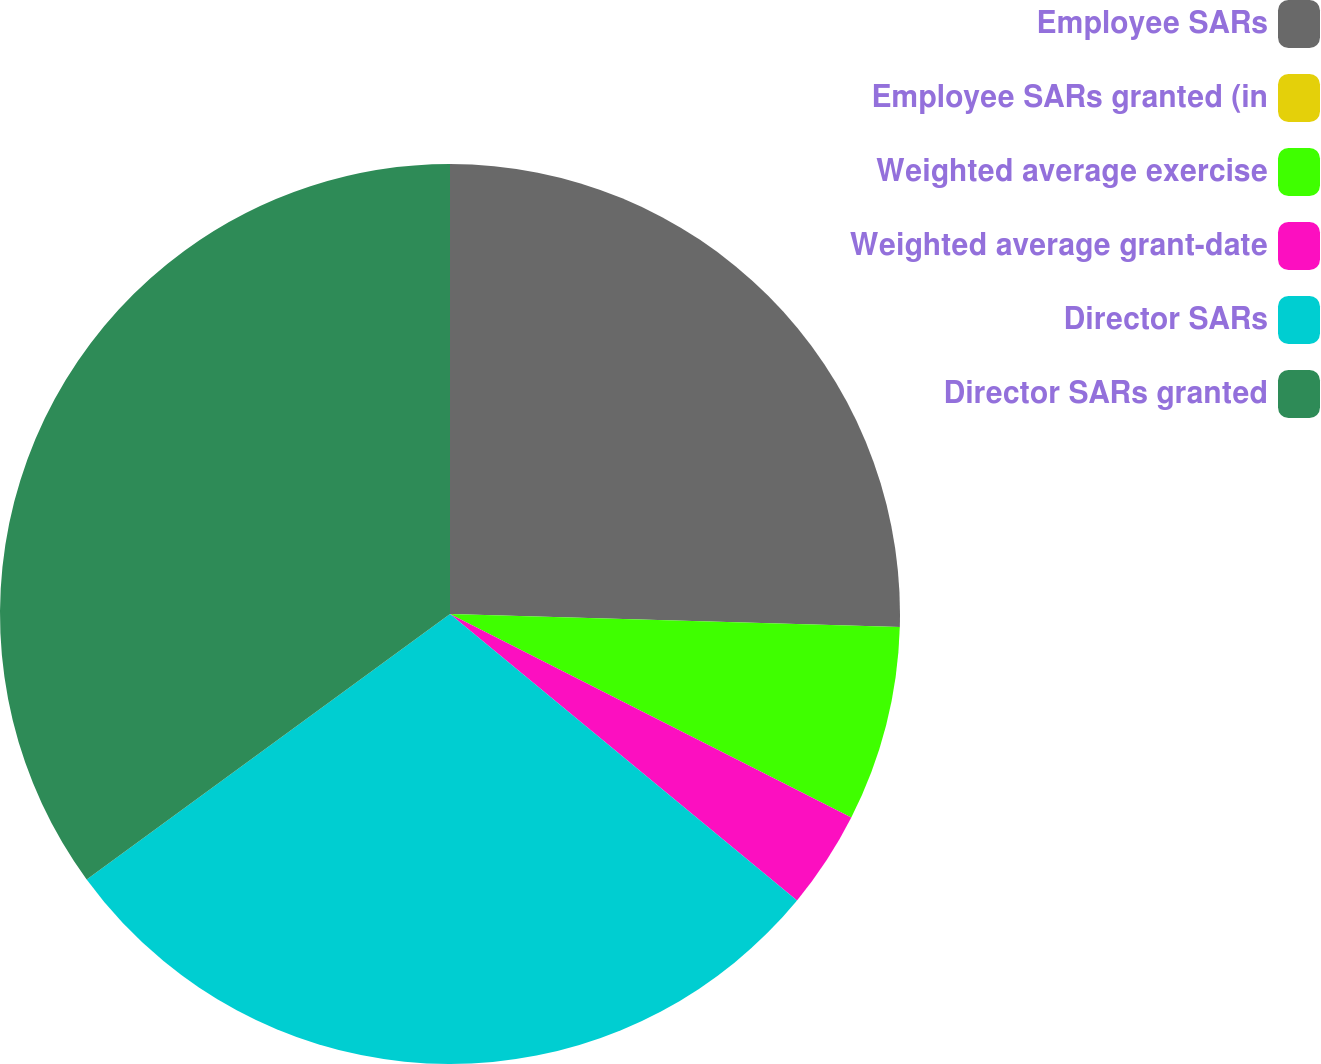Convert chart to OTSL. <chart><loc_0><loc_0><loc_500><loc_500><pie_chart><fcel>Employee SARs<fcel>Employee SARs granted (in<fcel>Weighted average exercise<fcel>Weighted average grant-date<fcel>Director SARs<fcel>Director SARs granted<nl><fcel>25.46%<fcel>0.0%<fcel>7.01%<fcel>3.51%<fcel>28.97%<fcel>35.04%<nl></chart> 